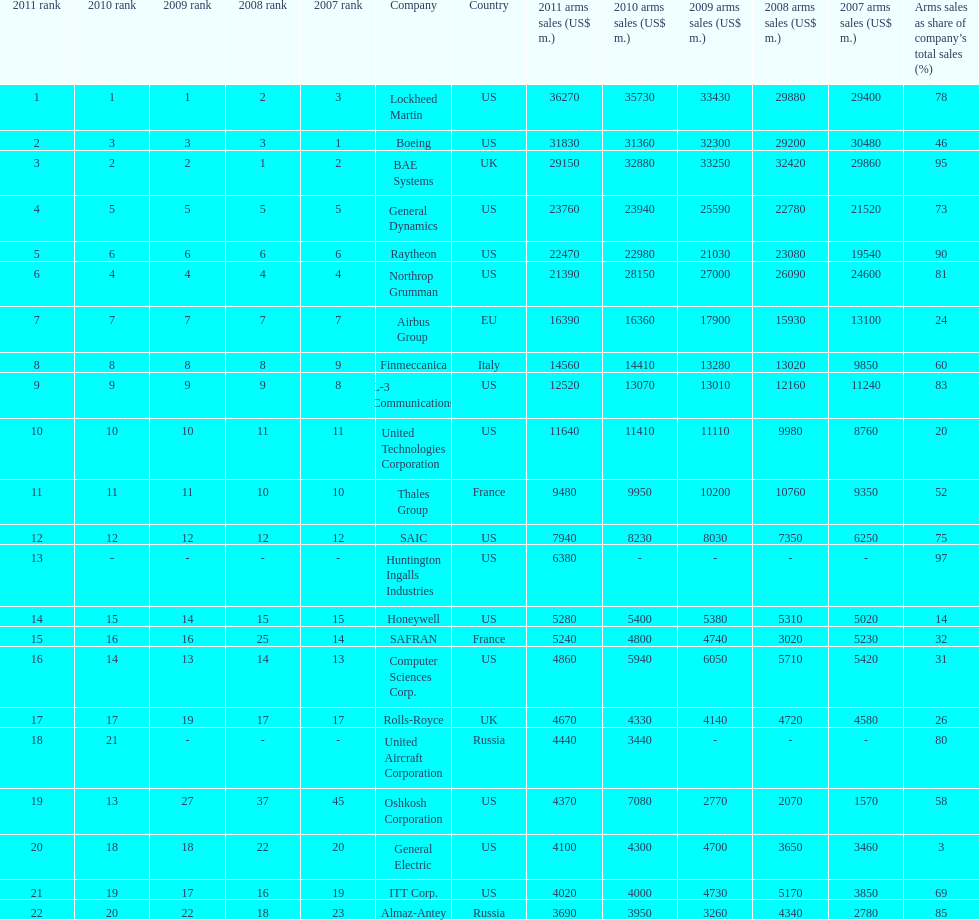Calculate the difference between boeing's 2010 arms sales and raytheon's 2010 arms sales. 8380. 